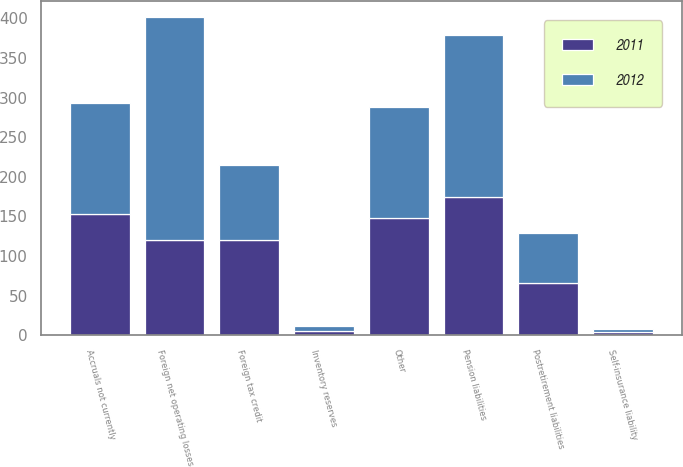Convert chart. <chart><loc_0><loc_0><loc_500><loc_500><stacked_bar_chart><ecel><fcel>Accruals not currently<fcel>Postretirement liabilities<fcel>Inventory reserves<fcel>Pension liabilities<fcel>Self-insurance liability<fcel>Foreign tax credit<fcel>Foreign net operating losses<fcel>Other<nl><fcel>2012<fcel>140.2<fcel>63.9<fcel>5.8<fcel>203.8<fcel>3.4<fcel>94.6<fcel>282.3<fcel>140<nl><fcel>2011<fcel>153.1<fcel>65.6<fcel>5.8<fcel>174.7<fcel>3.9<fcel>120<fcel>120<fcel>147.6<nl></chart> 